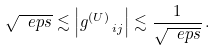<formula> <loc_0><loc_0><loc_500><loc_500>\sqrt { \ e p s } \lesssim \left | { g ^ { ( U ) } } _ { \, i j } \right | \lesssim \frac { 1 } { \sqrt { \ e p s } } \, .</formula> 